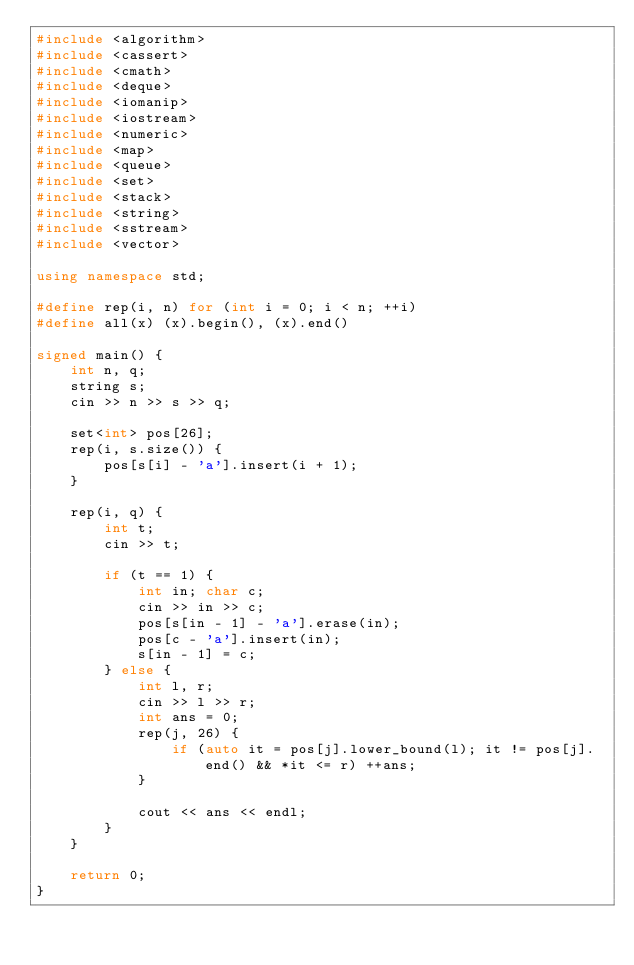Convert code to text. <code><loc_0><loc_0><loc_500><loc_500><_C++_>#include <algorithm>
#include <cassert>
#include <cmath>
#include <deque>
#include <iomanip>
#include <iostream>
#include <numeric>
#include <map>
#include <queue>
#include <set>
#include <stack>
#include <string>
#include <sstream>
#include <vector>

using namespace std;

#define rep(i, n) for (int i = 0; i < n; ++i)
#define all(x) (x).begin(), (x).end()

signed main() {
    int n, q;
    string s;
    cin >> n >> s >> q;

    set<int> pos[26];
    rep(i, s.size()) {
        pos[s[i] - 'a'].insert(i + 1);
    }

    rep(i, q) {
        int t;
        cin >> t;

        if (t == 1) {
            int in; char c;
            cin >> in >> c;
            pos[s[in - 1] - 'a'].erase(in);
            pos[c - 'a'].insert(in);
            s[in - 1] = c;
        } else {
            int l, r;
            cin >> l >> r;
            int ans = 0;
            rep(j, 26) {
                if (auto it = pos[j].lower_bound(l); it != pos[j].end() && *it <= r) ++ans;
            }

            cout << ans << endl;
        }
    } 

    return 0;
}</code> 